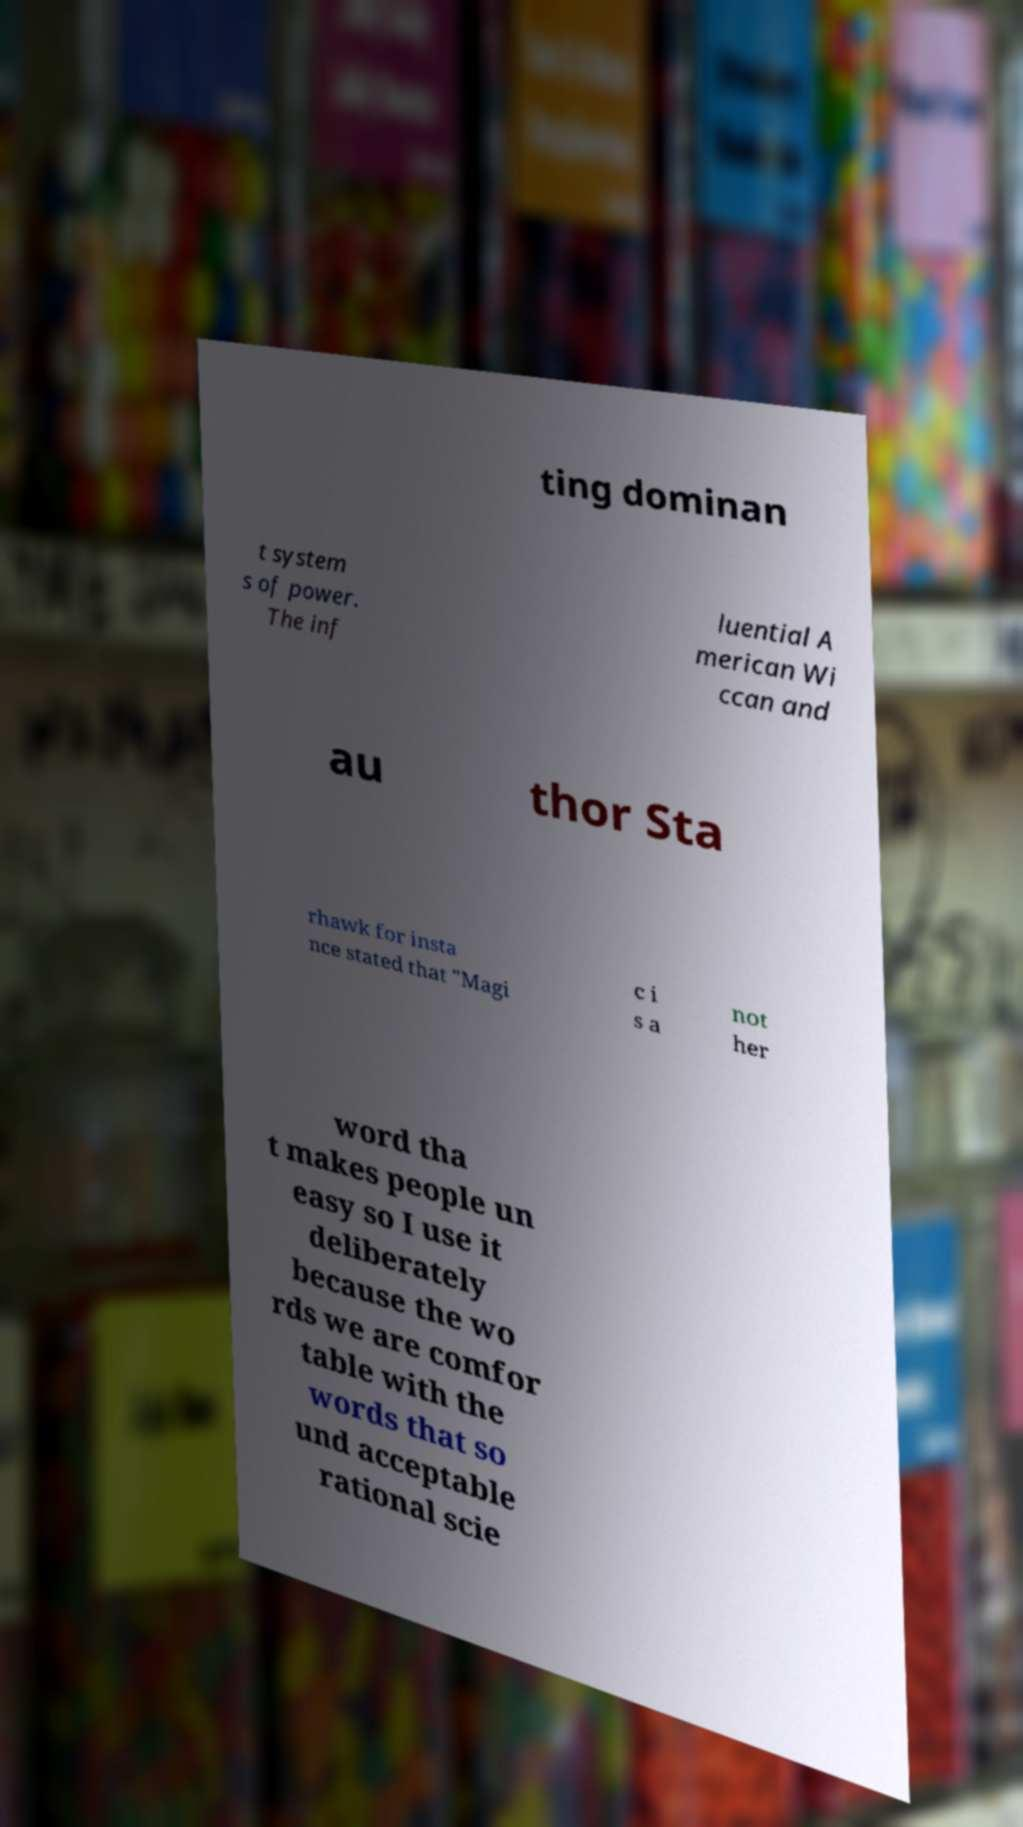What messages or text are displayed in this image? I need them in a readable, typed format. ting dominan t system s of power. The inf luential A merican Wi ccan and au thor Sta rhawk for insta nce stated that "Magi c i s a not her word tha t makes people un easy so I use it deliberately because the wo rds we are comfor table with the words that so und acceptable rational scie 